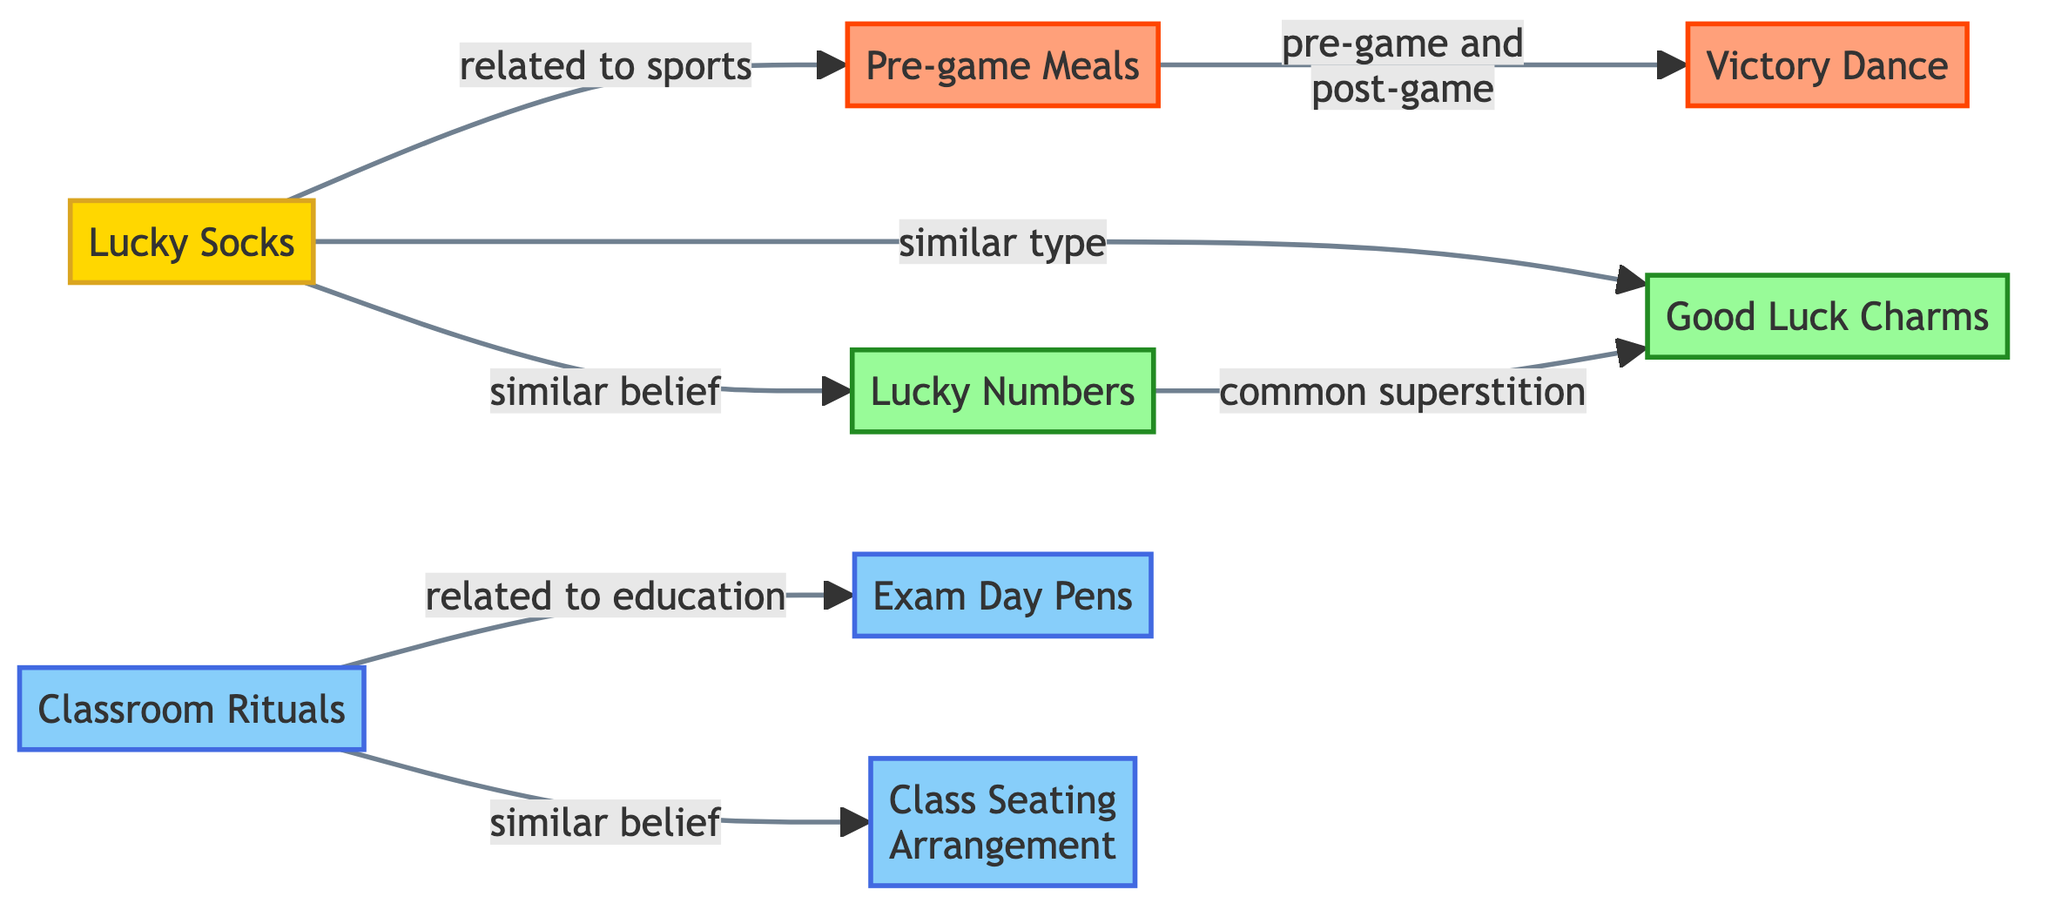What is the label of the node that represents personal superstitions? The node representing personal superstitions is labeled "Lucky Socks." It is categorized under the group of personal superstitions in the diagram.
Answer: Lucky Socks How many nodes are there in the diagram? By counting the listed items, there are a total of 8 nodes present in the diagram.
Answer: 8 What is the relationship between "Classroom Rituals" and "Exam Day Pens"? The relationship is indicated by an edge labeled "related to education," showing the connection between these two education superstitions.
Answer: related to education Which superstitions are associated with sports? "Lucky Socks," "Pre-game Meals," and "Victory Dance" are connected directly or indirectly to sports, with edges explicitly mentioning their relationships to the sports category.
Answer: Lucky Socks, Pre-game Meals, Victory Dance What type of superstition does "Lucky Numbers" represent? "Lucky Numbers" is categorized as a "common superstition," which is indicated in the group classification of the node.
Answer: common superstitions Which two nodes are linked by a "similar belief"? The nodes "Lucky Socks" and "Lucky Numbers" share a connection labeled "similar belief," linking the idea of personal superstitions to common superstitions.
Answer: Lucky Socks, Lucky Numbers How many education-related superstitions are shown in the diagram? There are three education-related superstitions: "Classroom Rituals," "Exam Day Pens," and "Class Seating Arrangement." They can be identified by checking the education group classification.
Answer: 3 What connects "Pre-game Meals" to "Victory Dance"? "Pre-game Meals" is connected to "Victory Dance" by an edge labeled "pre-game and post-game," indicating a relationship that ties them both to sports rituals before and after games.
Answer: pre-game and post-game 